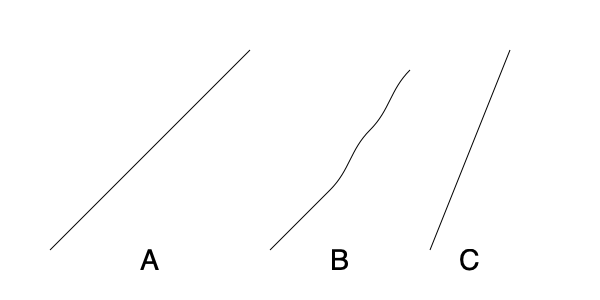Which silhouette best represents the proper body positioning for a high jump technique known as the Fosbury Flop? To determine the correct silhouette for the Fosbury Flop high jump technique, let's analyze each silhouette:

1. Silhouette A: This shows a linear progression from ground to peak, which is not characteristic of the Fosbury Flop. The Fosbury Flop involves a more curved approach and back-arched position.

2. Silhouette B: This silhouette depicts a curved path with a pronounced arch in the middle. This closely resembles the Fosbury Flop technique, where the jumper's body forms an arch as they clear the bar with their back facing down.

3. Silhouette C: While this shows a curved path, it's too simplistic and doesn't capture the nuanced body positioning of the Fosbury Flop.

The Fosbury Flop, invented by Dick Fosbury in the 1960s, revolutionized high jumping. It involves:
1. A curved approach run
2. A takeoff from the outside foot
3. Turning the body to face upwards during the jump
4. Arching the back over the bar
5. Landing on the shoulders and back

Silhouette B best captures this technique, showing the curved approach and the arched back position that is crucial for clearing the bar efficiently.
Answer: Silhouette B 